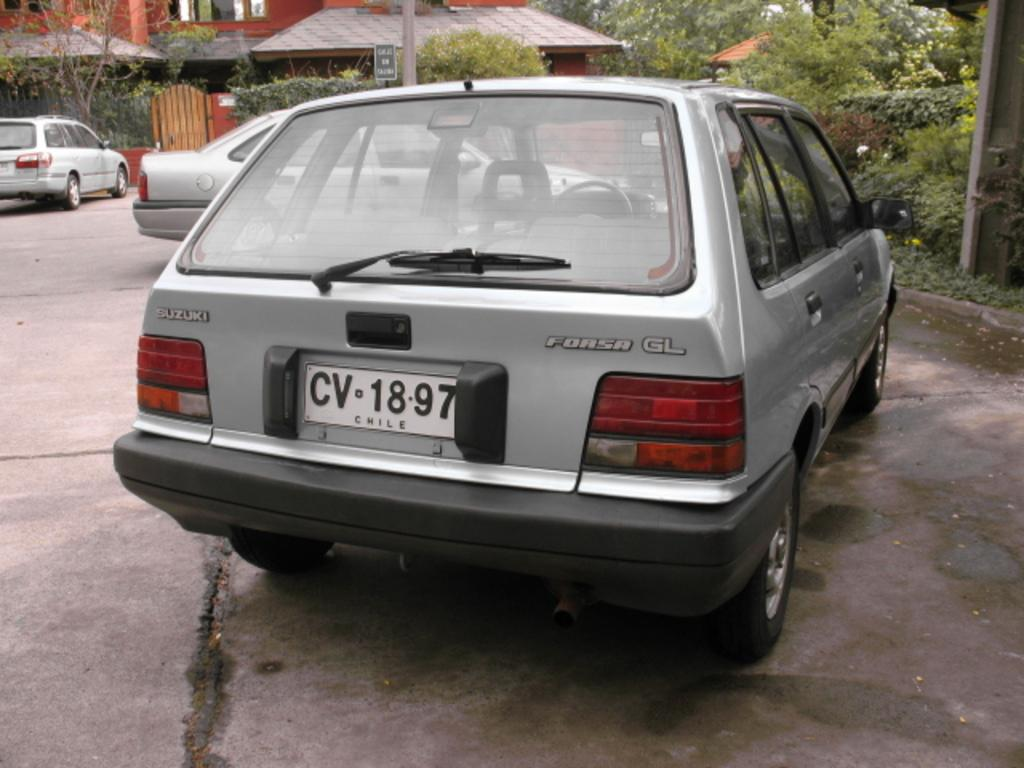Provide a one-sentence caption for the provided image. A grey Forsa GL station wagon is parked in a driveway. 